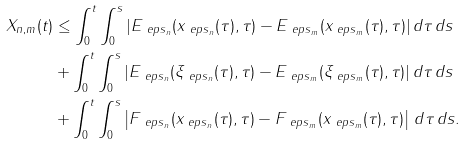Convert formula to latex. <formula><loc_0><loc_0><loc_500><loc_500>X _ { n , m } ( t ) & \leq \int _ { 0 } ^ { t } \int _ { 0 } ^ { s } | E _ { \ e p s _ { n } } ( x _ { \ e p s _ { n } } ( \tau ) , \tau ) - E _ { \ e p s _ { m } } ( x _ { \ e p s _ { m } } ( \tau ) , \tau ) | \, d \tau \, d s \\ & + \int _ { 0 } ^ { t } \int _ { 0 } ^ { s } | E _ { \ e p s _ { n } } ( \xi _ { \ e p s _ { n } } ( \tau ) , \tau ) - E _ { \ e p s _ { m } } ( \xi _ { \ e p s _ { m } } ( \tau ) , \tau ) | \, d \tau \, d s \\ & + \int _ { 0 } ^ { t } \int _ { 0 } ^ { s } \left | F _ { \ e p s _ { n } } ( x _ { \ e p s _ { n } } ( \tau ) , \tau ) - F _ { \ e p s _ { m } } ( x _ { \ e p s _ { m } } ( \tau ) , \tau ) \right | \, d \tau \, d s .</formula> 